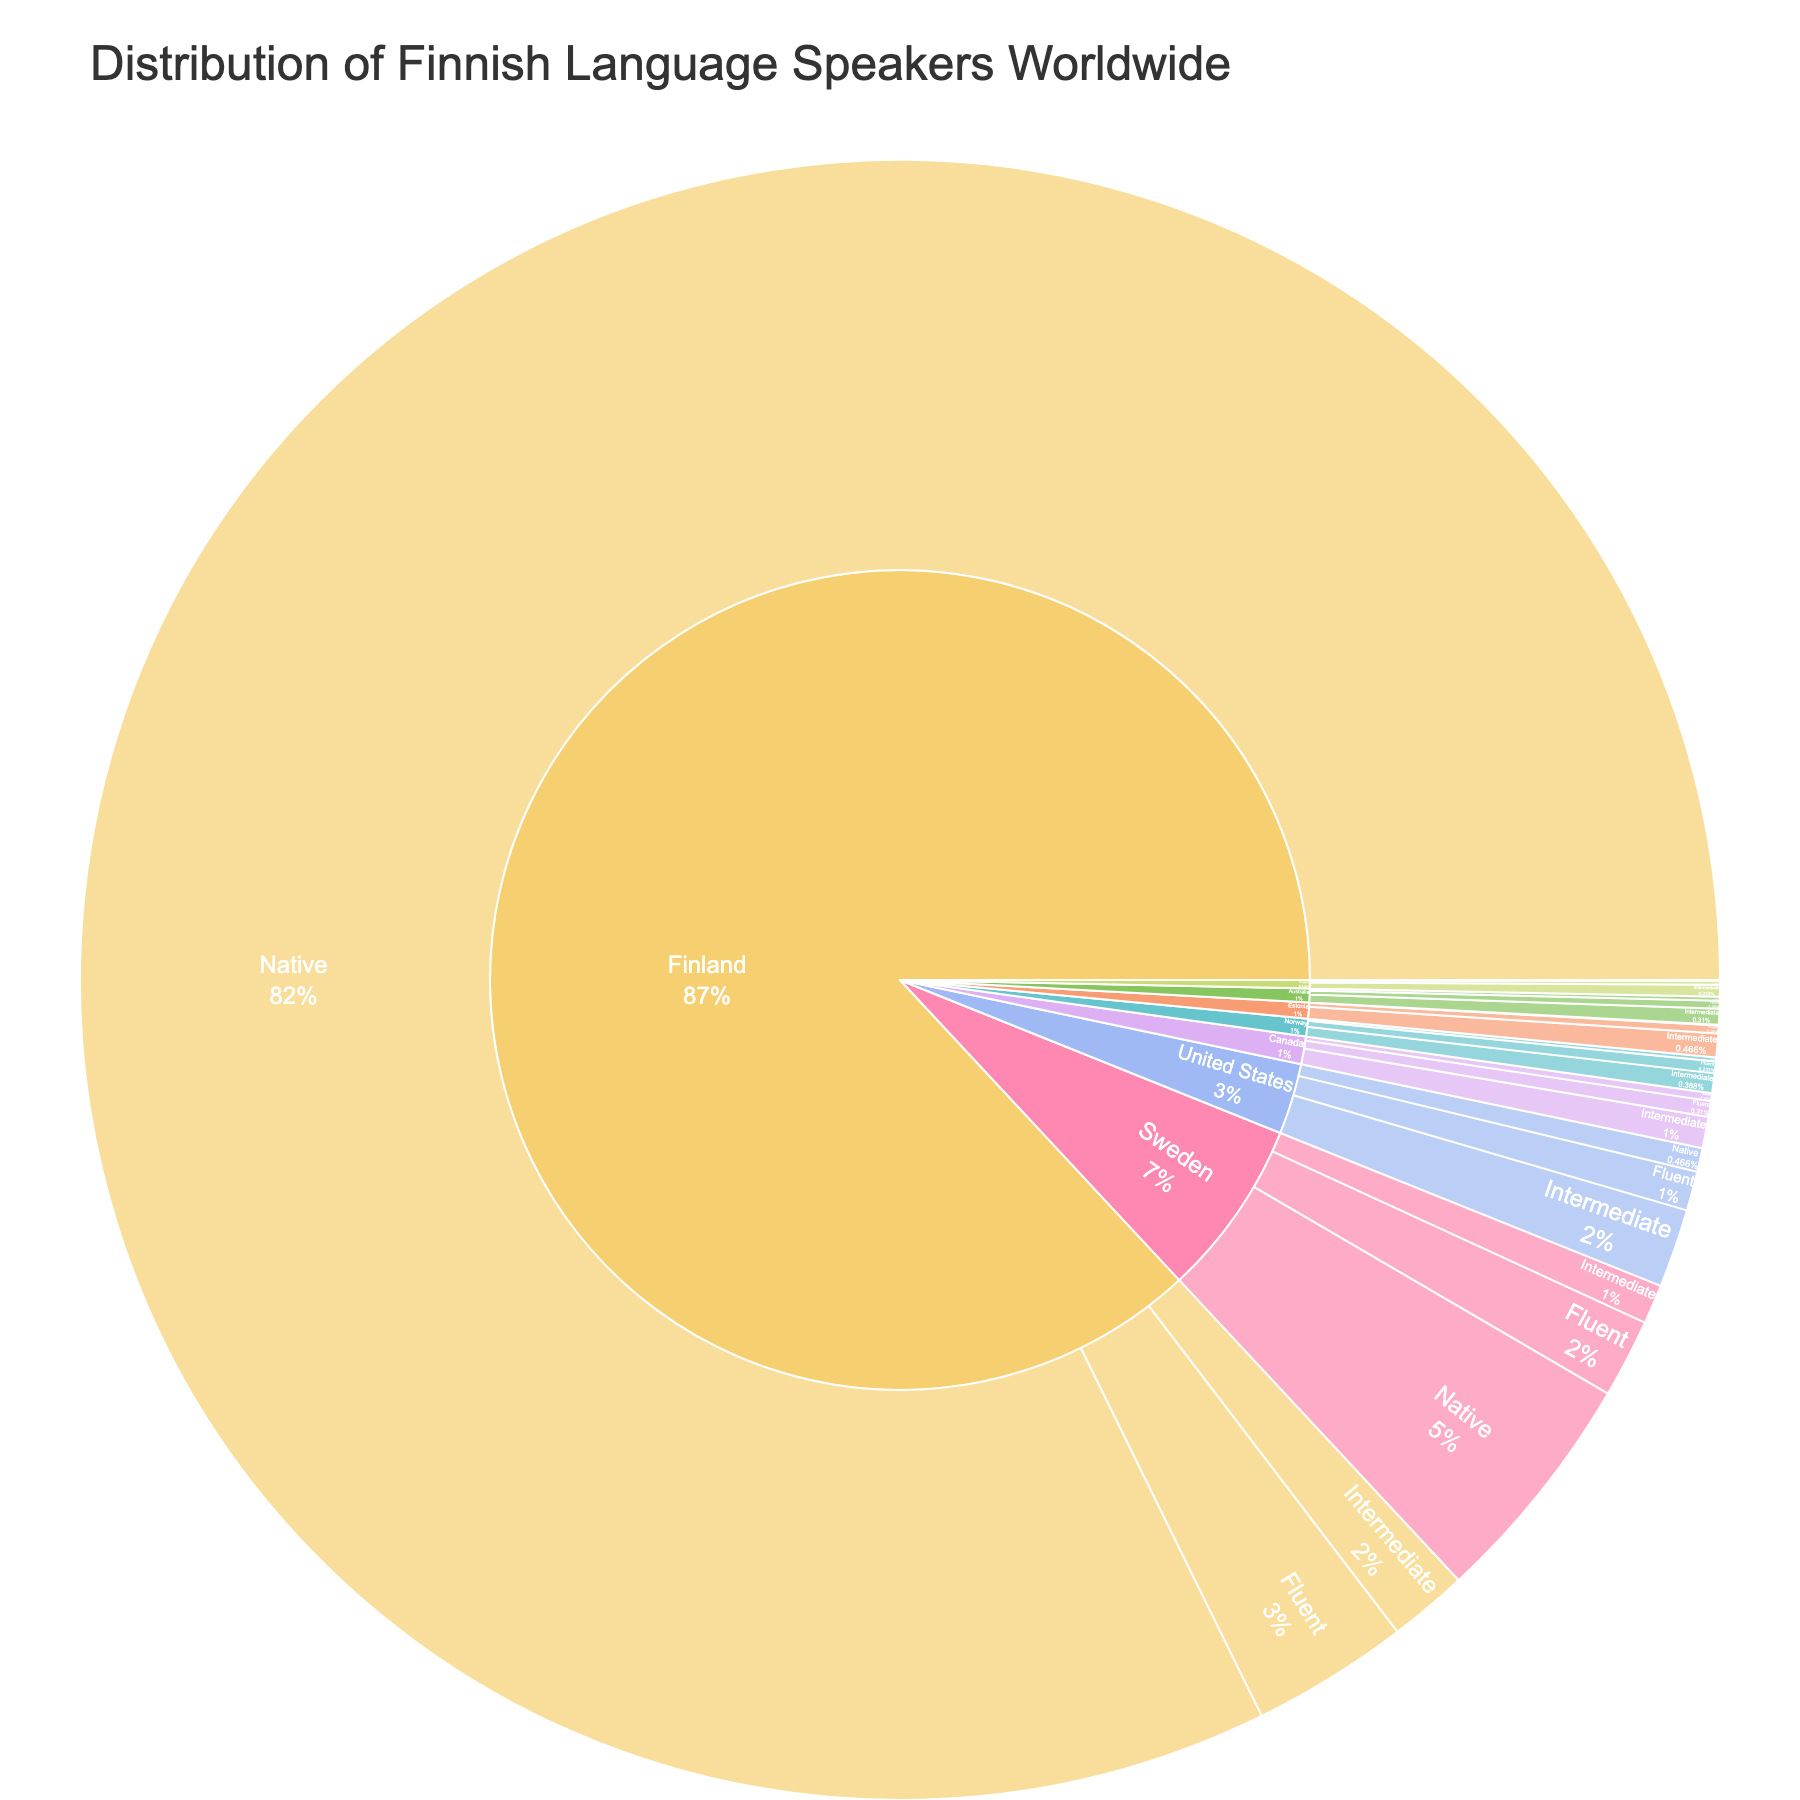What is the total number of Finnish language speakers in Finland? You need to sum the counts of all proficiency levels in Finland. The values are 5,300,000 (Native), 200,000 (Fluent), and 100,000 (Intermediate). The total is 5,300,000 + 200,000 + 100,000 = 5,600,000.
Answer: 5,600,000 Which country has the highest number of Finnish native speakers? You need to compare the number of native Finnish speakers in all countries listed. Finland has 5,300,000, Sweden has 300,000, and other countries have fewer. Hence, Finland has the highest count.
Answer: Finland How does the number of intermediate Finnish speakers in the United States compare to those in Canada? You compare the intermediate Finnish speaker counts of the United States (100,000) and Canada (40,000). The United States has more intermediate Finnish speakers.
Answer: United States has more What is the percentage of fluent Finnish speakers out of the total Finnish speakers in Sweden? First, sum the counts of all proficiency levels in Sweden: 300,000 (Native) + 100,000 (Fluent) + 50,000 (Intermediate) = 450,000. Then, calculate the percentage of fluent speakers: (100,000 / 450,000) * 100 = 22.22%.
Answer: 22.22% What proportion of Finnish language speakers in Australia are native speakers? Sum the counts of all proficiency levels in Australia: 5,000 (Native) + 10,000 (Fluent) + 20,000 (Intermediate) = 35,000. Then, calculate the proportion of native speakers: 5,000 / 35,000 = 0.1429, or 14.29%.
Answer: 14.29% Which country has the least number of Finnish fluent speakers? Compare the fluent Finnish speaker counts in all listed countries. Estonia and Russia both have the least number of fluent speakers, with 10,000 and 5,000, respectively.
Answer: Russia How many more native Finnish speakers does Finland have compared to Sweden? Subtract the number of native Finnish speakers in Sweden (300,000) from the number in Finland (5,300,000). 5,300,000 - 300,000 = 5,000,000.
Answer: 5,000,000 What is the combined number of Finnish speakers (all proficiency levels) in Norway and Estonia? Sum all proficiency level counts for Norway (5,000 + 15,000 + 25,000) and Estonia (1,000 + 10,000 + 30,000). The combined total is 45,000 (Norway) + 41,000 (Estonia) = 86,000.
Answer: 86,000 Which proficiency level has the highest count of Finnish speakers in the United States? Compare the counts of different proficiency levels in the United States: 30,000 (Native), 50,000 (Fluent), 100,000 (Intermediate). Intermediate has the highest count.
Answer: Intermediate How does the number of fluent Finnish speakers in Canada compare to fluent speakers in Australia? Compare the fluent Finnish speaker counts in Canada (20,000) and Australia (10,000). Canada has more fluent Finnish speakers.
Answer: Canada has more 